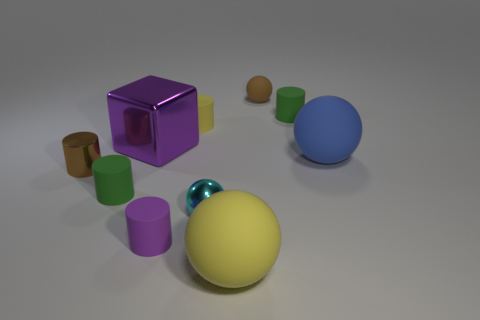How many metal things are big yellow objects or big purple cubes?
Offer a very short reply. 1. Are there fewer tiny matte cylinders to the left of the large yellow object than small red matte things?
Offer a very short reply. No. There is a small green thing to the right of the tiny green object in front of the small green rubber cylinder behind the large blue rubber object; what shape is it?
Your answer should be compact. Cylinder. Does the tiny metal ball have the same color as the tiny rubber sphere?
Provide a succinct answer. No. Are there more gray matte spheres than brown shiny cylinders?
Keep it short and to the point. No. How many other objects are the same material as the cyan sphere?
Provide a succinct answer. 2. How many things are either small red cylinders or small green matte cylinders that are on the right side of the big purple object?
Your answer should be compact. 1. Is the number of blocks less than the number of small purple matte cubes?
Ensure brevity in your answer.  No. What color is the big matte object that is left of the rubber ball behind the tiny green cylinder that is on the right side of the brown rubber thing?
Your response must be concise. Yellow. Does the cyan thing have the same material as the brown ball?
Offer a very short reply. No. 